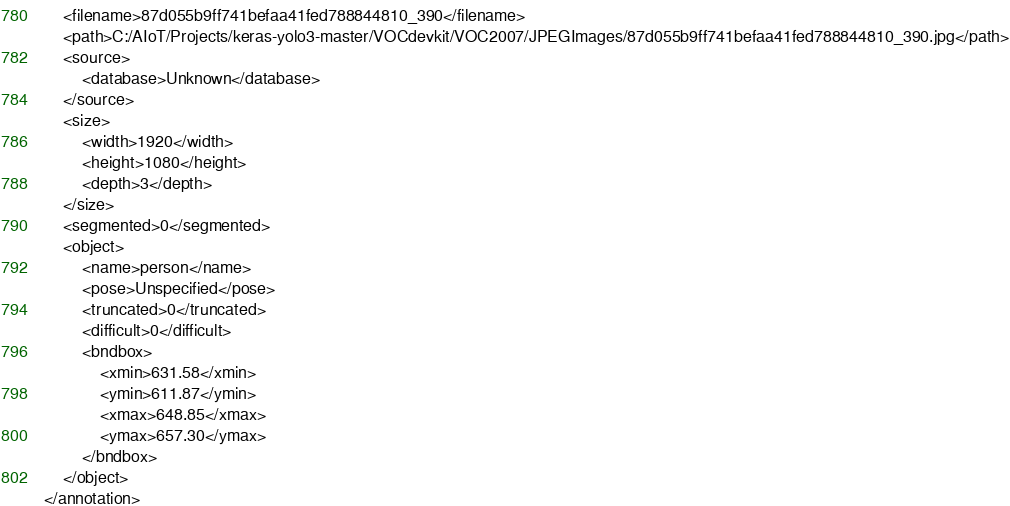Convert code to text. <code><loc_0><loc_0><loc_500><loc_500><_XML_>	<filename>87d055b9ff741befaa41fed788844810_390</filename>
	<path>C:/AIoT/Projects/keras-yolo3-master/VOCdevkit/VOC2007/JPEGImages/87d055b9ff741befaa41fed788844810_390.jpg</path>
	<source>
		<database>Unknown</database>
	</source>
	<size>
		<width>1920</width>
		<height>1080</height>
		<depth>3</depth>
	</size>
	<segmented>0</segmented>
	<object>
		<name>person</name>
		<pose>Unspecified</pose>
		<truncated>0</truncated>
		<difficult>0</difficult>
		<bndbox>
			<xmin>631.58</xmin>
			<ymin>611.87</ymin>
			<xmax>648.85</xmax>
			<ymax>657.30</ymax>
		</bndbox>
	</object>
</annotation>
</code> 